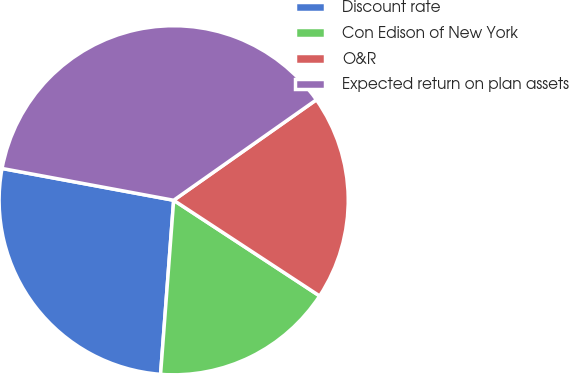<chart> <loc_0><loc_0><loc_500><loc_500><pie_chart><fcel>Discount rate<fcel>Con Edison of New York<fcel>O&R<fcel>Expected return on plan assets<nl><fcel>26.72%<fcel>16.96%<fcel>19.0%<fcel>37.32%<nl></chart> 